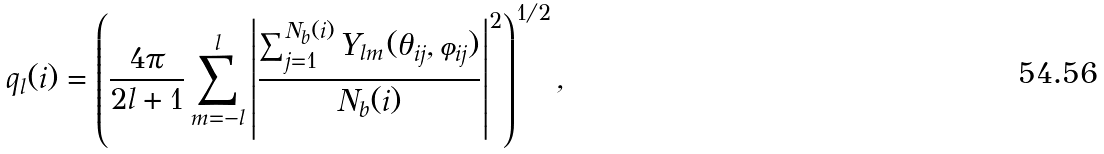<formula> <loc_0><loc_0><loc_500><loc_500>q _ { l } ( i ) = \left ( \frac { 4 \pi } { 2 l + 1 } \sum _ { m = - l } ^ { l } \left | \frac { \sum _ { j = 1 } ^ { N _ { b } ( i ) } Y _ { l m } ( \theta _ { i j } , \varphi _ { i j } ) } { N _ { b } ( i ) } \right | ^ { 2 } \right ) ^ { 1 / 2 } ,</formula> 